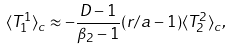<formula> <loc_0><loc_0><loc_500><loc_500>\langle T _ { 1 } ^ { 1 } \rangle _ { c } \approx - \frac { D - 1 } { \beta _ { 2 } - 1 } ( r / a - 1 ) \langle T _ { 2 } ^ { 2 } \rangle _ { c } ,</formula> 